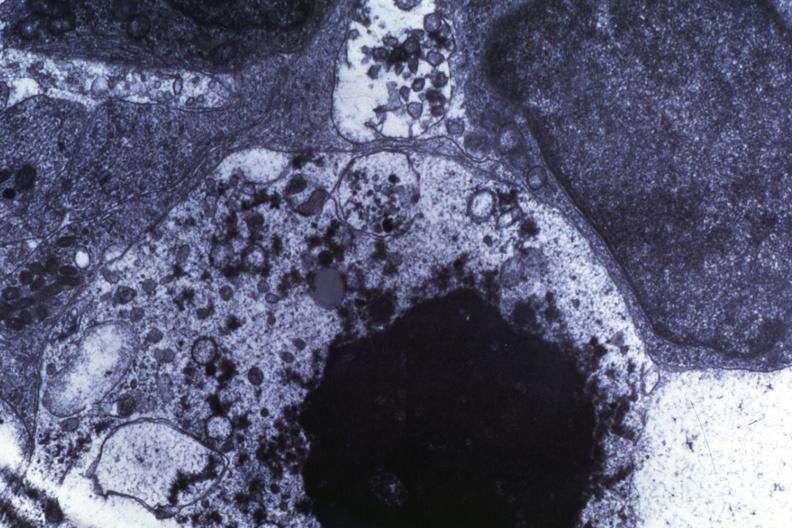what is present?
Answer the question using a single word or phrase. Medulloblastoma 